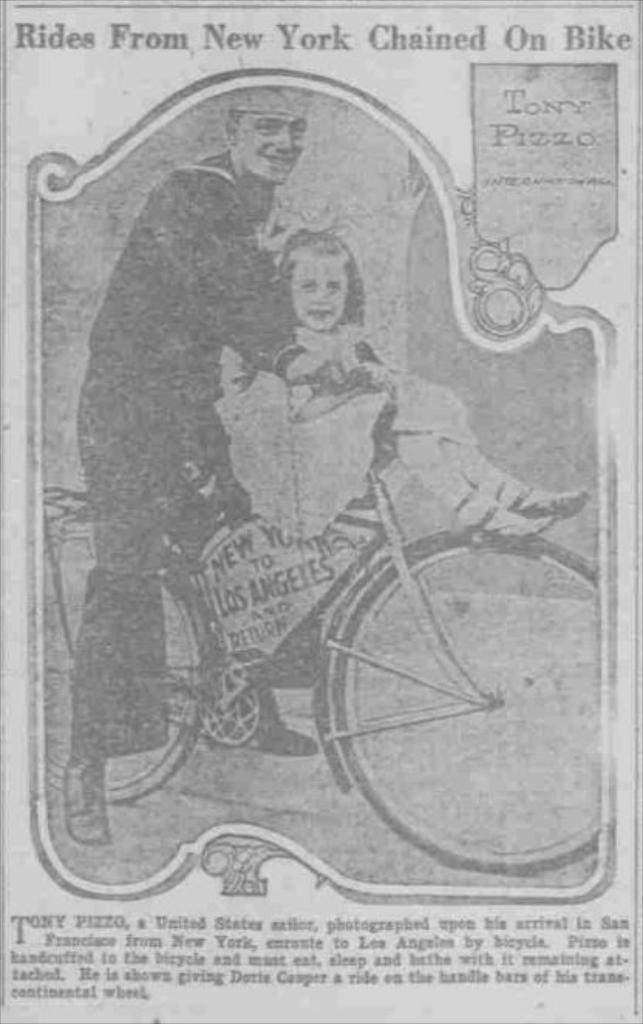What is present in the picture that is related to writing or reading? There is a paper in the picture. How many people are in the picture? There are two persons in the picture. What mode of transportation can be seen in the picture? There is a bike in the picture. Can you describe any text or description in the picture? Yes, there is some description in the picture. Are there any balloons visible in the picture? There is no mention of balloons in the provided facts, so we cannot determine if there are any in the image. Are the two persons in the picture sisters? The provided facts do not mention any familial relationship between the two persons, so we cannot determine if they are sisters. 